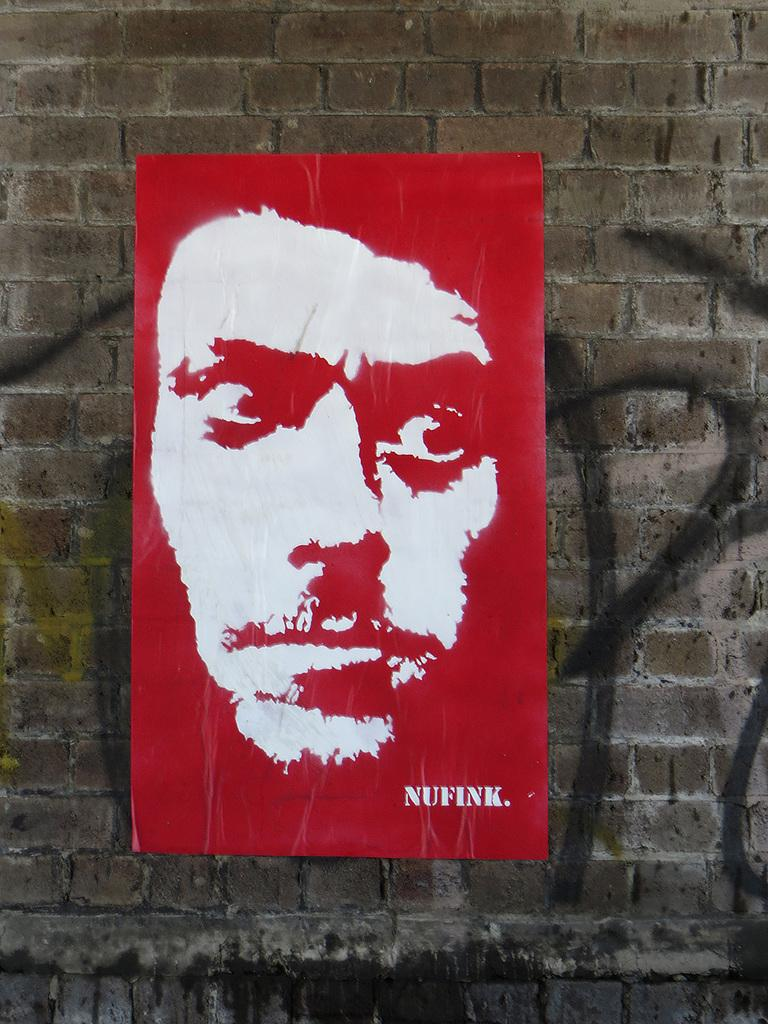<image>
Summarize the visual content of the image. Nufink has a red and white poster of a man's face on a brick wall. 